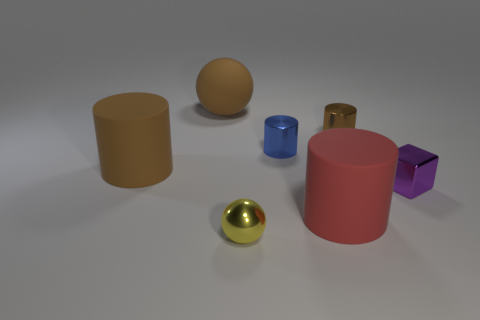Subtract all red rubber cylinders. How many cylinders are left? 3 Subtract all blue cylinders. How many cylinders are left? 3 Add 3 purple blocks. How many objects exist? 10 Subtract all green cylinders. Subtract all green balls. How many cylinders are left? 4 Subtract all spheres. How many objects are left? 5 Subtract all tiny blue metallic cylinders. Subtract all large spheres. How many objects are left? 5 Add 3 small yellow balls. How many small yellow balls are left? 4 Add 6 tiny red matte objects. How many tiny red matte objects exist? 6 Subtract 1 yellow balls. How many objects are left? 6 